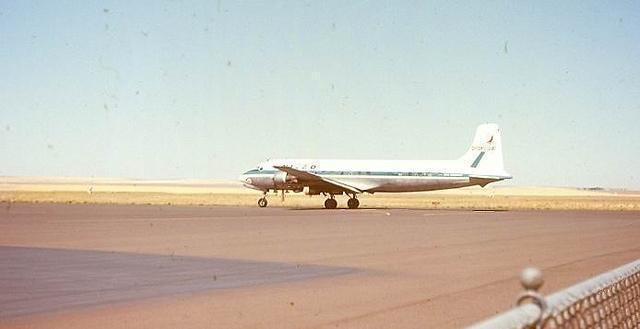How many planes are shown?
Give a very brief answer. 1. 